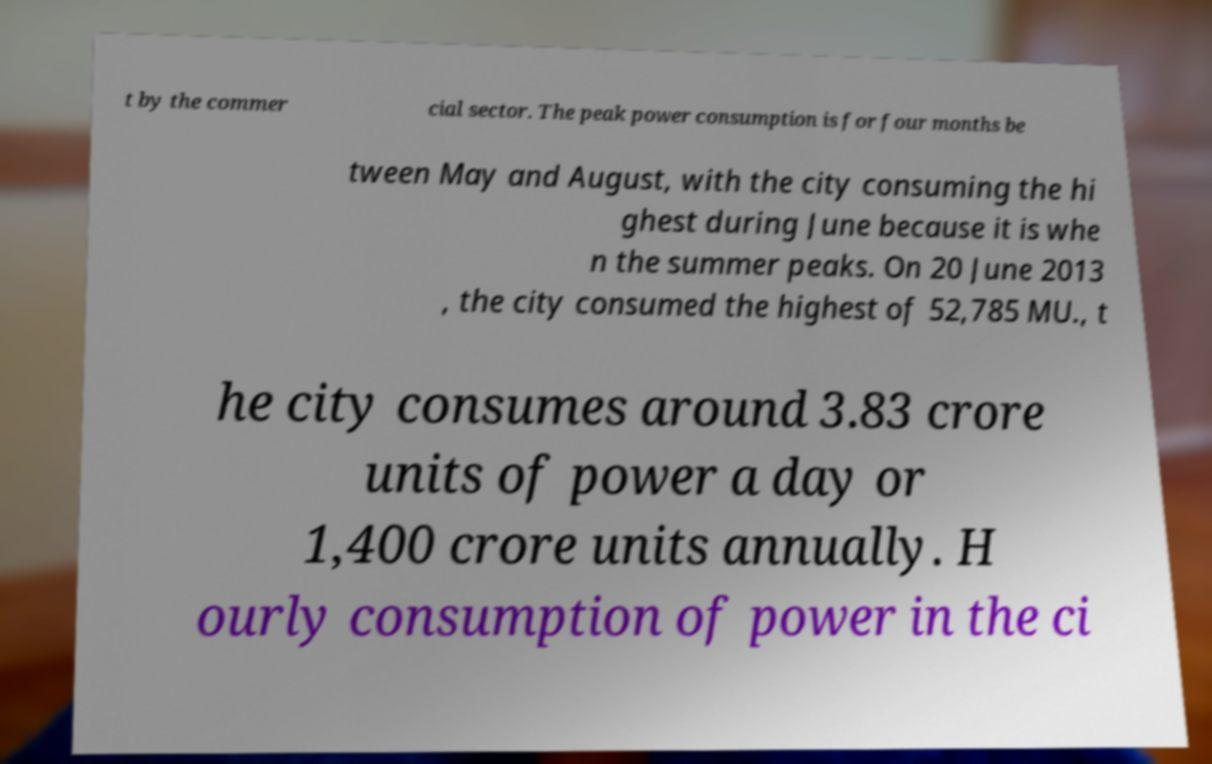Can you read and provide the text displayed in the image?This photo seems to have some interesting text. Can you extract and type it out for me? t by the commer cial sector. The peak power consumption is for four months be tween May and August, with the city consuming the hi ghest during June because it is whe n the summer peaks. On 20 June 2013 , the city consumed the highest of 52,785 MU., t he city consumes around 3.83 crore units of power a day or 1,400 crore units annually. H ourly consumption of power in the ci 